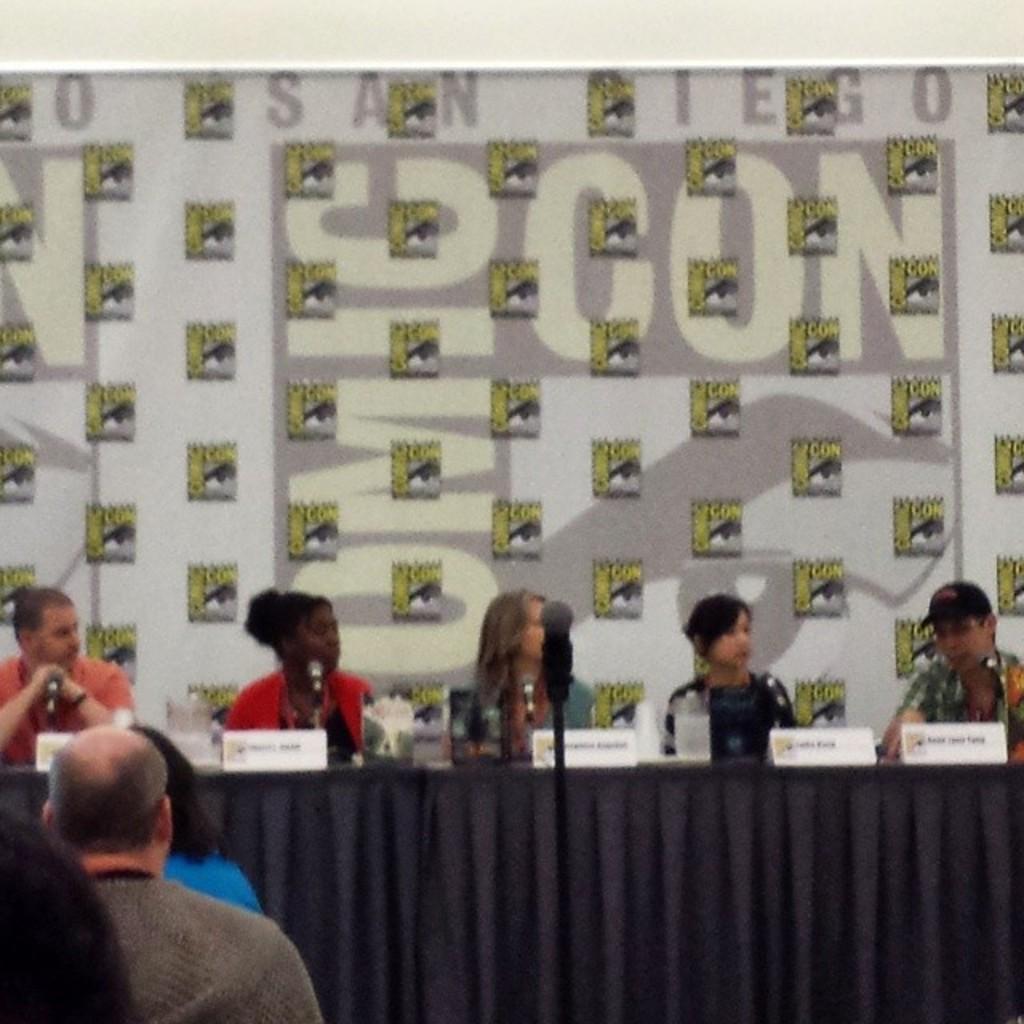Please provide a concise description of this image. We can see few persons sitting on chairs in front of a table and on the table we can see boards, bottle. On the background there is one flexi. Here we can see few audience at the left side of the picture. 